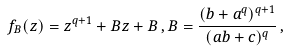<formula> <loc_0><loc_0><loc_500><loc_500>f _ { B } ( z ) = z ^ { q + 1 } + B z + B \, , B = \frac { ( b + a ^ { q } ) ^ { q + 1 } } { ( a b + c ) ^ { q } } \, ,</formula> 